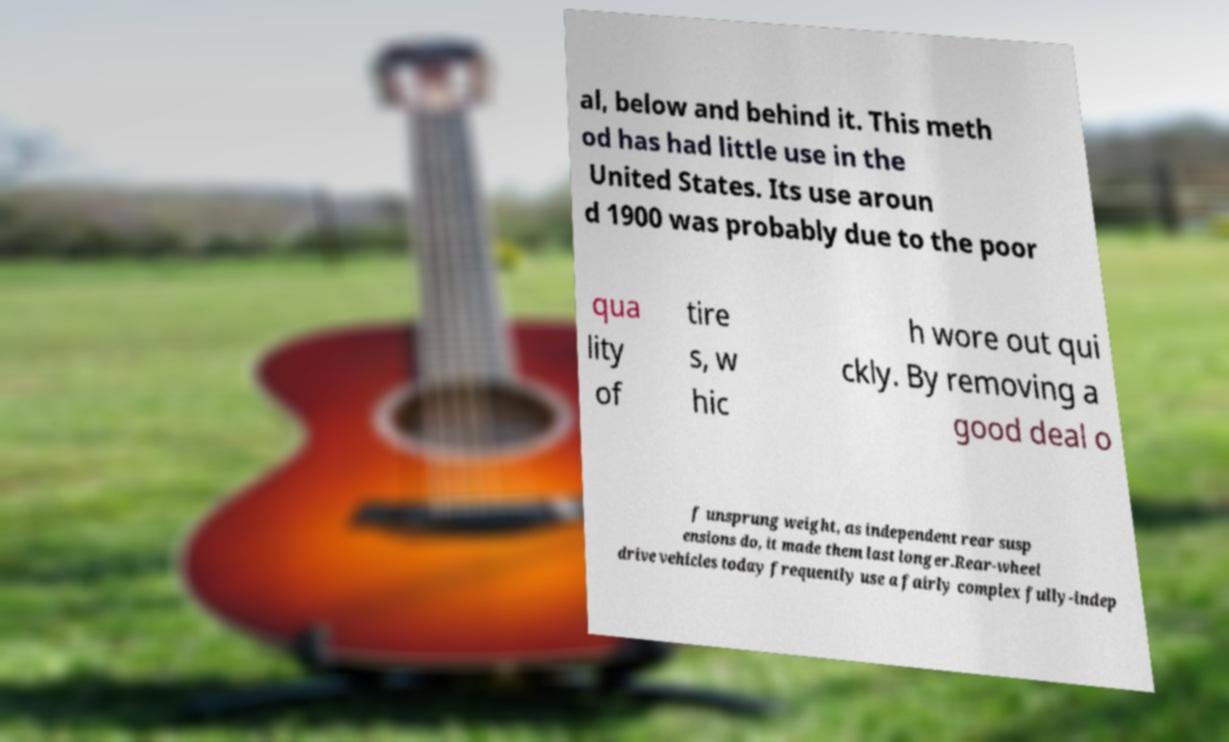What messages or text are displayed in this image? I need them in a readable, typed format. al, below and behind it. This meth od has had little use in the United States. Its use aroun d 1900 was probably due to the poor qua lity of tire s, w hic h wore out qui ckly. By removing a good deal o f unsprung weight, as independent rear susp ensions do, it made them last longer.Rear-wheel drive vehicles today frequently use a fairly complex fully-indep 